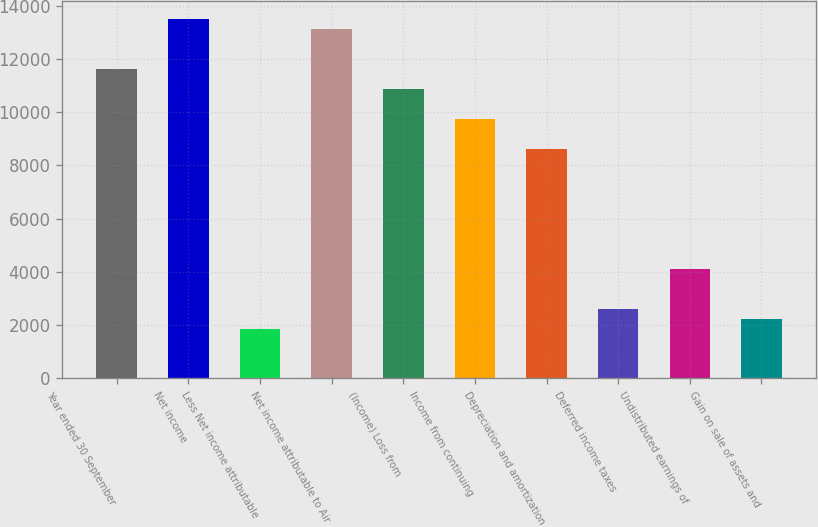Convert chart. <chart><loc_0><loc_0><loc_500><loc_500><bar_chart><fcel>Year ended 30 September<fcel>Net income<fcel>Less Net income attributable<fcel>Net income attributable to Air<fcel>(Income) Loss from<fcel>Income from continuing<fcel>Depreciation and amortization<fcel>Deferred income taxes<fcel>Undistributed earnings of<fcel>Gain on sale of assets and<nl><fcel>11622<fcel>13496.2<fcel>1876.45<fcel>13121.4<fcel>10872.4<fcel>9747.88<fcel>8623.39<fcel>2626.11<fcel>4125.43<fcel>2251.28<nl></chart> 